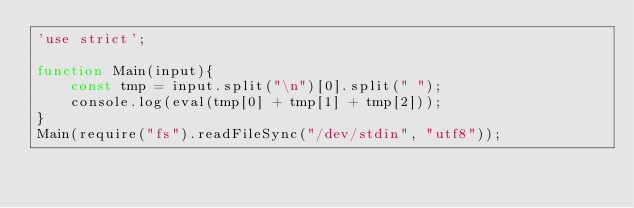Convert code to text. <code><loc_0><loc_0><loc_500><loc_500><_JavaScript_>'use strict';
 
function Main(input){
    const tmp = input.split("\n")[0].split(" ");
    console.log(eval(tmp[0] + tmp[1] + tmp[2]));
}
Main(require("fs").readFileSync("/dev/stdin", "utf8"));</code> 